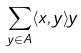<formula> <loc_0><loc_0><loc_500><loc_500>\sum _ { y \in A } \langle x , y \rangle y</formula> 